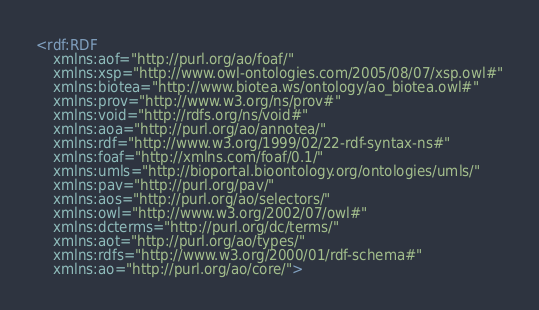<code> <loc_0><loc_0><loc_500><loc_500><_XML_><rdf:RDF
    xmlns:aof="http://purl.org/ao/foaf/"
    xmlns:xsp="http://www.owl-ontologies.com/2005/08/07/xsp.owl#"
    xmlns:biotea="http://www.biotea.ws/ontology/ao_biotea.owl#"
    xmlns:prov="http://www.w3.org/ns/prov#"
    xmlns:void="http://rdfs.org/ns/void#"
    xmlns:aoa="http://purl.org/ao/annotea/"
    xmlns:rdf="http://www.w3.org/1999/02/22-rdf-syntax-ns#"
    xmlns:foaf="http://xmlns.com/foaf/0.1/"
    xmlns:umls="http://bioportal.bioontology.org/ontologies/umls/"
    xmlns:pav="http://purl.org/pav/"
    xmlns:aos="http://purl.org/ao/selectors/"
    xmlns:owl="http://www.w3.org/2002/07/owl#"
    xmlns:dcterms="http://purl.org/dc/terms/"
    xmlns:aot="http://purl.org/ao/types/"
    xmlns:rdfs="http://www.w3.org/2000/01/rdf-schema#"
    xmlns:ao="http://purl.org/ao/core/"></code> 